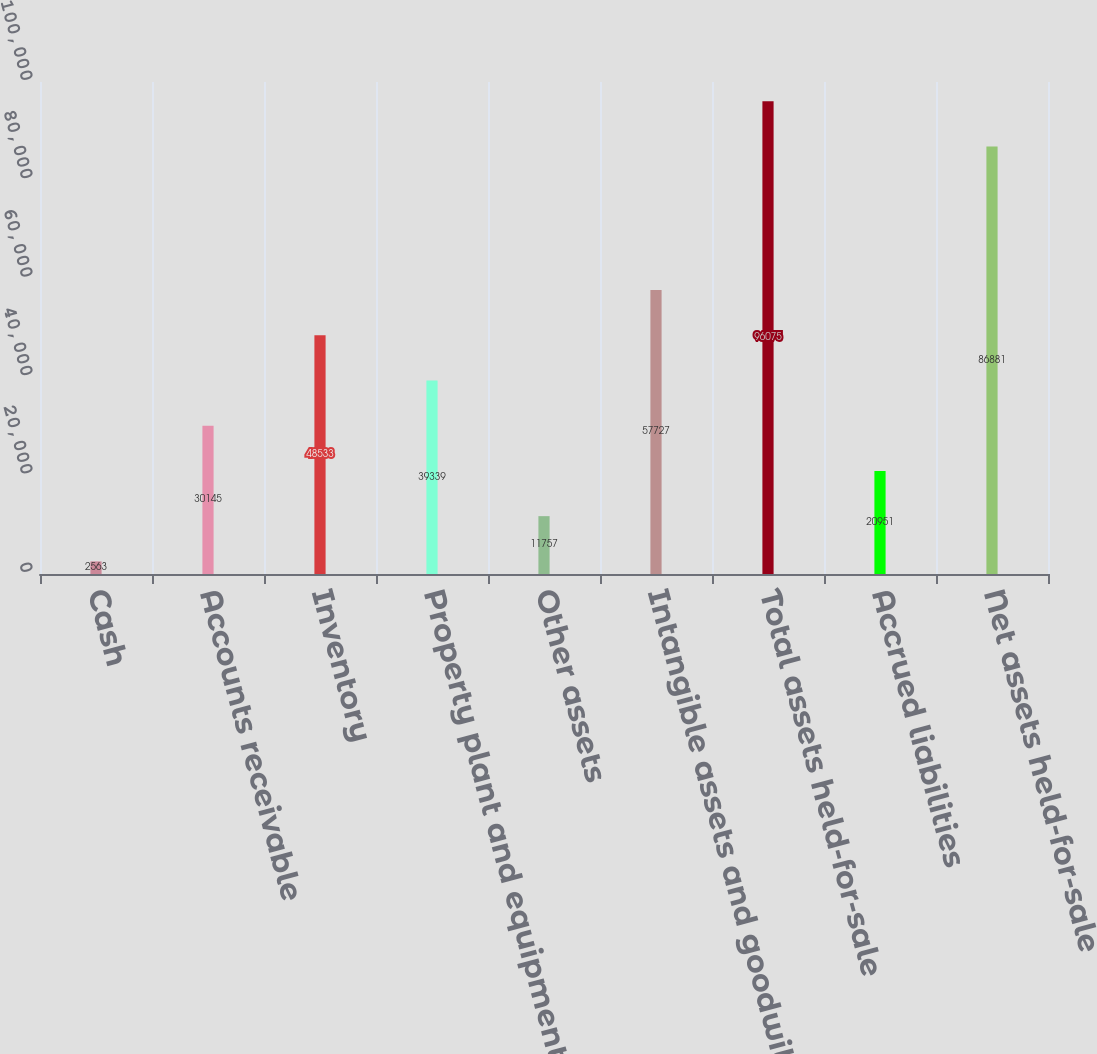Convert chart to OTSL. <chart><loc_0><loc_0><loc_500><loc_500><bar_chart><fcel>Cash<fcel>Accounts receivable<fcel>Inventory<fcel>Property plant and equipment<fcel>Other assets<fcel>Intangible assets and goodwill<fcel>Total assets held-for-sale<fcel>Accrued liabilities<fcel>Net assets held-for-sale<nl><fcel>2563<fcel>30145<fcel>48533<fcel>39339<fcel>11757<fcel>57727<fcel>96075<fcel>20951<fcel>86881<nl></chart> 